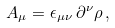<formula> <loc_0><loc_0><loc_500><loc_500>A _ { \mu } = \epsilon _ { \mu \nu } \, \partial ^ { \nu } \rho \, ,</formula> 